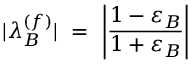<formula> <loc_0><loc_0><loc_500><loc_500>| \lambda _ { B } ^ { ( f ) } | \ = \ \left | \frac { 1 - \varepsilon _ { B } } { 1 + \varepsilon _ { B } } \right |</formula> 